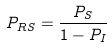<formula> <loc_0><loc_0><loc_500><loc_500>P _ { R S } = \frac { P _ { S } } { 1 - P _ { I } }</formula> 